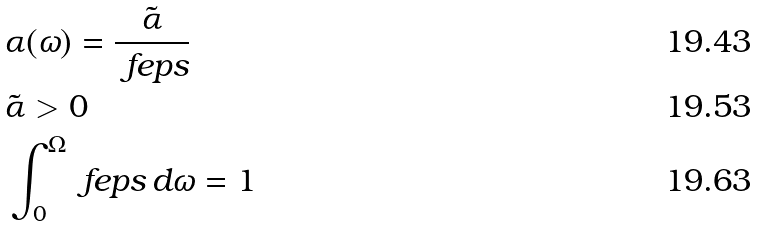<formula> <loc_0><loc_0><loc_500><loc_500>& \alpha ( \omega ) = \frac { \tilde { \alpha } } { \ f e p s } \\ & \tilde { \alpha } > 0 \\ & \int _ { 0 } ^ { \Omega } \ f e p s \, d \omega = 1</formula> 